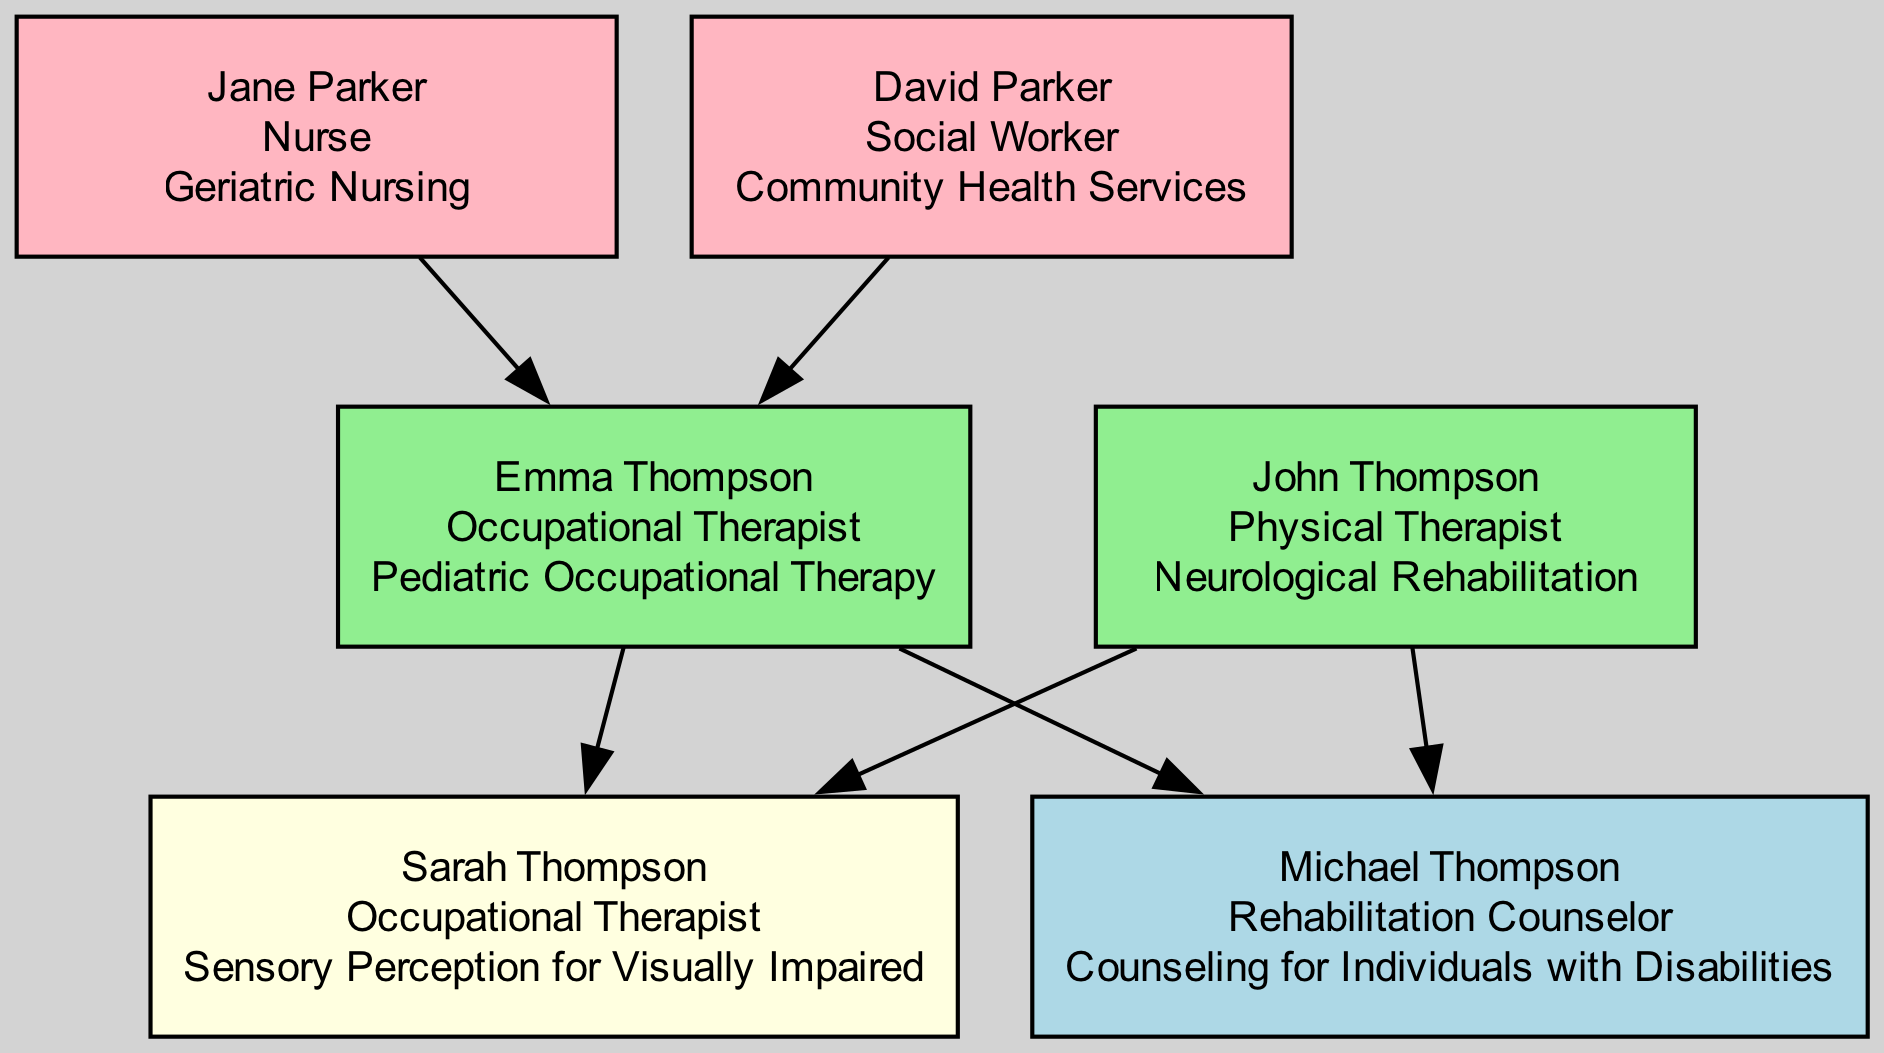What is the occupation of Sarah Thompson? The diagram shows that Sarah Thompson is an Occupational Therapist, which is stated clearly in her node.
Answer: Occupational Therapist How many siblings does Sarah Thompson have? By examining the relationships in the diagram, we see that Sarah has one brother, Michael Thompson.
Answer: 1 Who is the maternal grandmother of Sarah Thompson? The diagram indicates that Jane Parker holds the position of maternal grandmother, as shown in her relationship to Emma Thompson.
Answer: Jane Parker What is the specialization of Sarah Thompson? The node for Sarah Thompson identifies her specialization as Sensory Perception for Visually Impaired, making it straightforward to find the answer.
Answer: Sensory Perception for Visually Impaired Which family member is a Social Worker? The diagram specifies that David Parker is a Social Worker, as indicated in his career description within the node.
Answer: David Parker What is the relationship between Emma Thompson and Sarah Thompson? According to the diagram, Emma Thompson is listed as Sarah Thompson's mother, establishing a direct relationship.
Answer: Mother Which career is related to neurological rehabilitation in this family tree? The diagram shows that John Thompson is the Physical Therapist specializing in Neurological Rehabilitation, providing direct information about this specialization.
Answer: Physical Therapist How many individuals in the family tree work in healthcare-related fields? By counting the nodes, we find that four individuals (Sarah, Emma, John, and Jane) have careers in healthcare-related fields, specifically Occupational Therapy, Physical Therapy, and Nursing.
Answer: 4 What specialization does Michael Thompson focus on? The node for Michael Thompson indicates he specializes in Counseling for Individuals with Disabilities, which we can directly see in the diagram.
Answer: Counseling for Individuals with Disabilities 